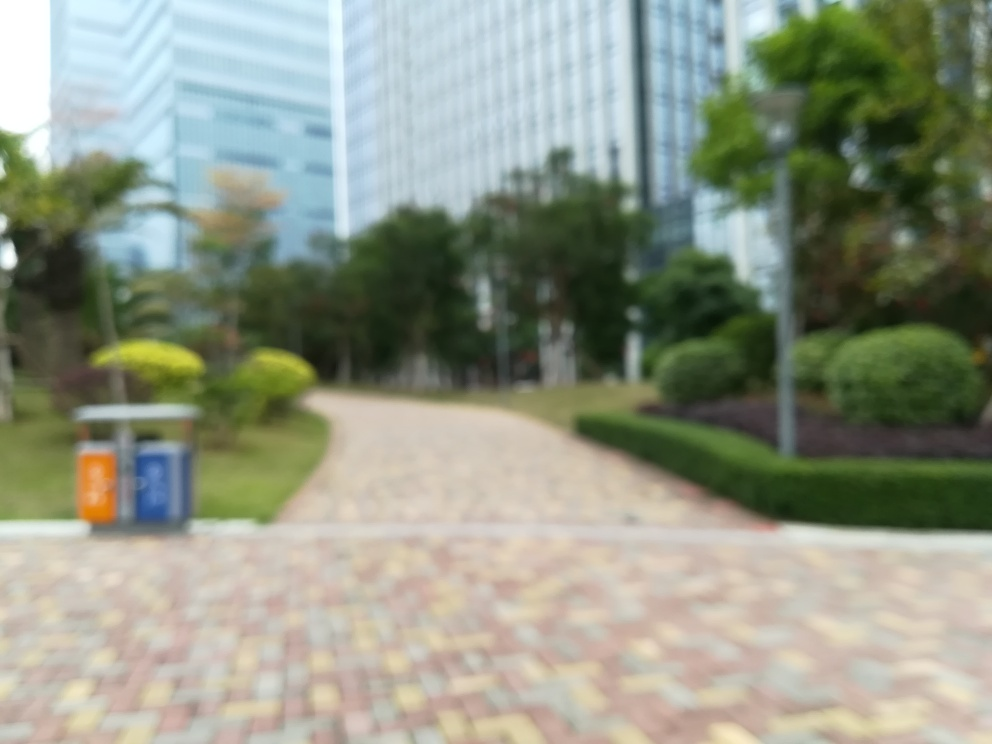Are there any quality issues with this image? Yes, the image is blurry, which obscures details such as the textures of the pavement and foliage, the architecture of the buildings, and any signage or people that might be present. This lack of clarity makes the image less useful for most purposes. 